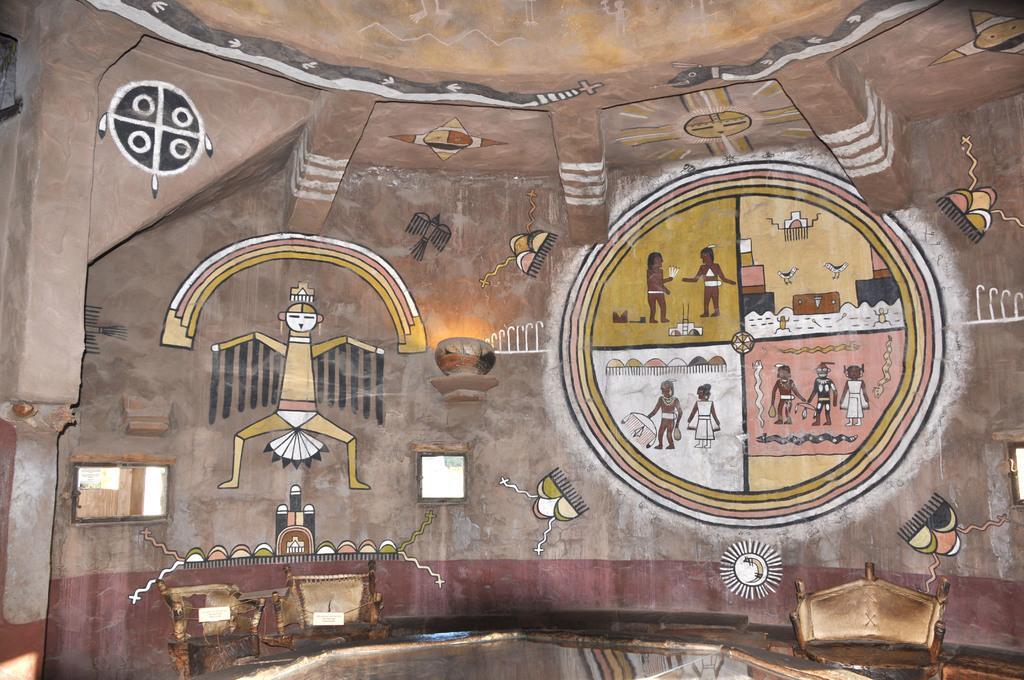In one or two sentences, can you explain what this image depicts? In the picture I can see a wall which has paintings of people and some other things. I can also see some other objects. 